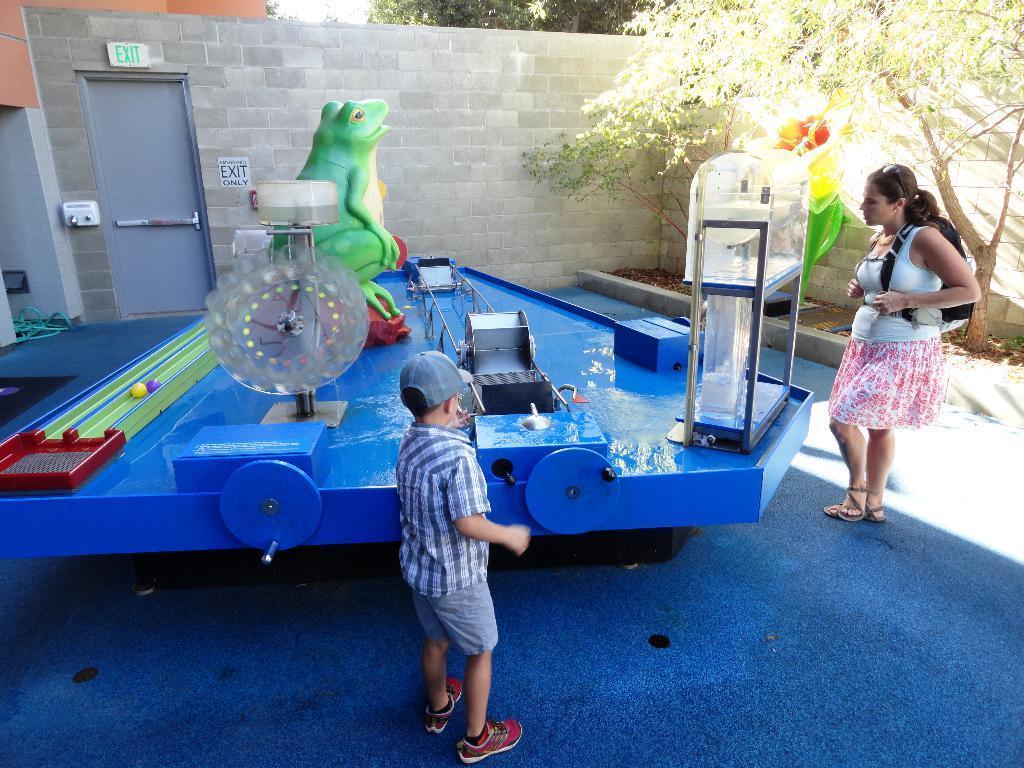Can you describe this image briefly? This images taken outdoors. In the background there are a few trees and there is a wall. There are two sign boards. There is a door. On the right side of the image there is a tree and a woman is standing on the floor. At the bottom of the image there is a mat on the floor. In the middle of the image there is a play station with a few toys and a kid is standing on the mat. 